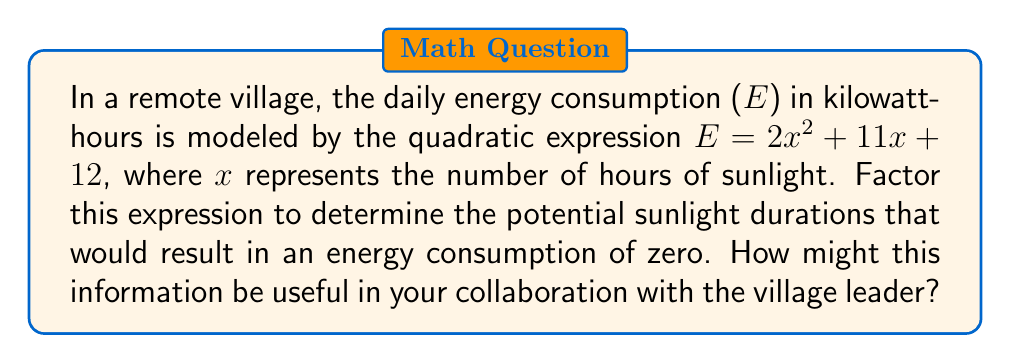Give your solution to this math problem. To factor the quadratic expression $E = 2x^2 + 11x + 12$, we'll follow these steps:

1) First, we need to find two numbers that multiply to give $2 \times 12 = 24$ and add up to 11.
   These numbers are 8 and 3.

2) We can rewrite the middle term using these numbers:
   $E = 2x^2 + 8x + 3x + 12$

3) Now we can factor by grouping:
   $E = 2x(x + 4) + 3(x + 4)$

4) We can factor out the common term $(x + 4)$:
   $E = (2x + 3)(x + 4)$

5) Therefore, the factored expression is:
   $E = (2x + 3)(x + 4)$

6) To find when energy consumption is zero, we set $E = 0$:
   $0 = (2x + 3)(x + 4)$

7) This equation is satisfied when either factor equals zero:
   $2x + 3 = 0$ or $x + 4 = 0$

8) Solving these equations:
   $x = -\frac{3}{2}$ or $x = -4$

The negative values for x are not practically meaningful in this context, as they would represent negative hours of sunlight. However, this analysis shows that energy consumption approaches zero as sunlight hours approach these values.

This information could be useful in collaborating with the village leader to:
1) Understand the relationship between sunlight and energy consumption.
2) Plan for energy storage or alternative sources during low-sunlight periods.
3) Optimize energy use based on predicted sunlight hours.
Answer: $E = (2x + 3)(x + 4)$ 